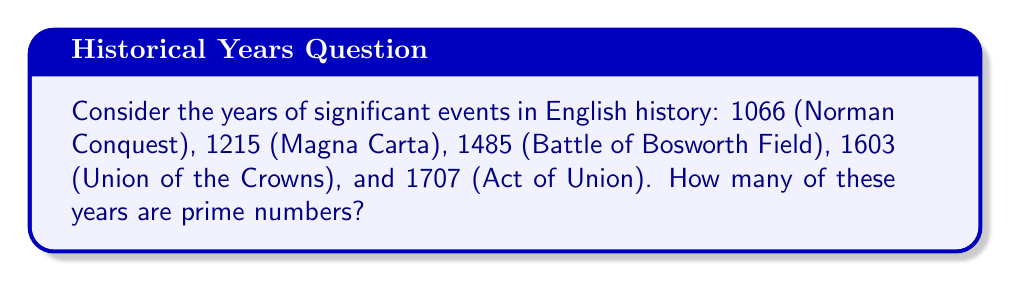Can you answer this question? To determine how many of these years are prime numbers, we need to check each year individually:

1. 1066: This number is even, so it's not prime.

2. 1215: To check if 1215 is prime, we need to see if it has any factors other than 1 and itself.
   $1215 = 3 \times 5 \times 81$
   Therefore, 1215 is not prime.

3. 1485: Again, let's check for factors:
   $1485 = 3 \times 5 \times 99$
   So, 1485 is not prime.

4. 1603: To check this number, we need to test potential factors up to its square root:
   $\sqrt{1603} \approx 40$
   After testing, we find that 1603 is only divisible by 1 and itself.
   Therefore, 1603 is prime.

5. 1707: Checking for factors:
   $1707 = 3 \times 569$
   Thus, 1707 is not prime.

Out of these five historically significant years, only one (1603) is a prime number.
Answer: 1 